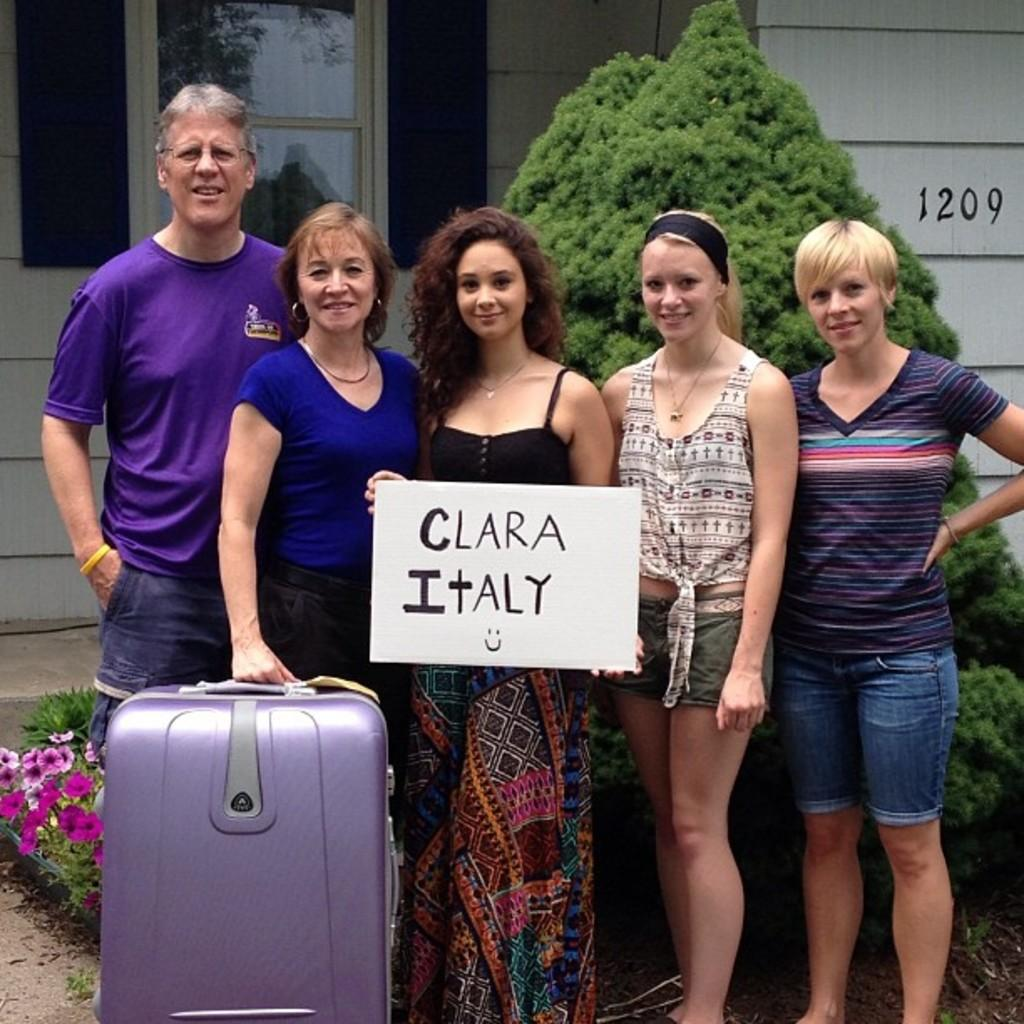How many people are in the image? There are four women and a man in the image, making a total of five people. What are the women and man doing in the image? The women and man are standing. Can you describe what one of the women is holding? One woman is holding a briefcase. What is the other woman holding? The other woman is holding a placard. What can be seen in the background of the image? There is a tree visible in the background of the image. What type of stomach ailment is the doctor treating in the image? There is no doctor or stomach ailment present in the image. How many bikes are visible in the image? There are no bikes visible in the image. 